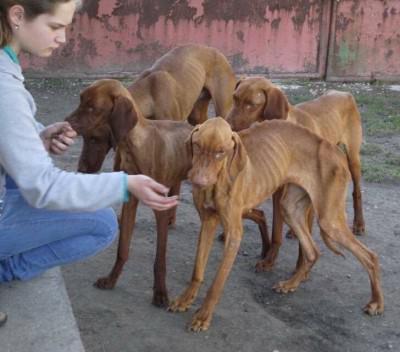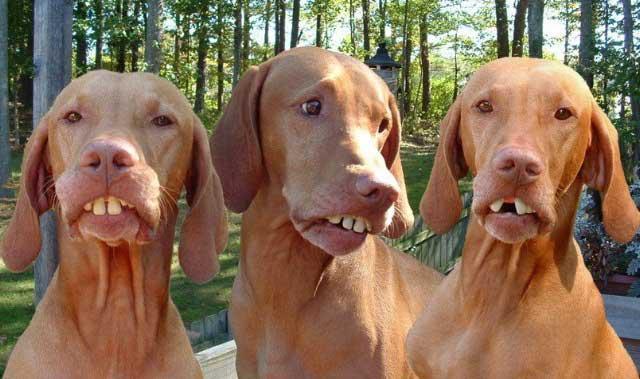The first image is the image on the left, the second image is the image on the right. Evaluate the accuracy of this statement regarding the images: "At least one dog is on a leash.". Is it true? Answer yes or no. No. The first image is the image on the left, the second image is the image on the right. Considering the images on both sides, is "Each image contains one dog, and the righthand dog has its pink tongue extended past its teeth." valid? Answer yes or no. No. 